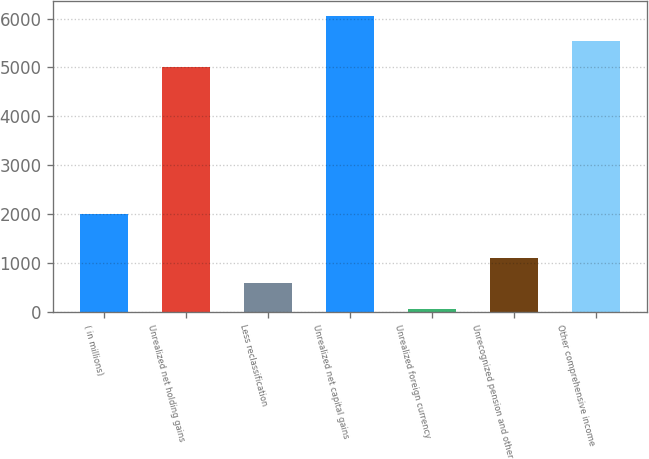Convert chart to OTSL. <chart><loc_0><loc_0><loc_500><loc_500><bar_chart><fcel>( in millions)<fcel>Unrealized net holding gains<fcel>Less reclassification<fcel>Unrealized net capital gains<fcel>Unrealized foreign currency<fcel>Unrecognized pension and other<fcel>Other comprehensive income<nl><fcel>2009<fcel>5015<fcel>586.6<fcel>6062.2<fcel>63<fcel>1110.2<fcel>5538.6<nl></chart> 